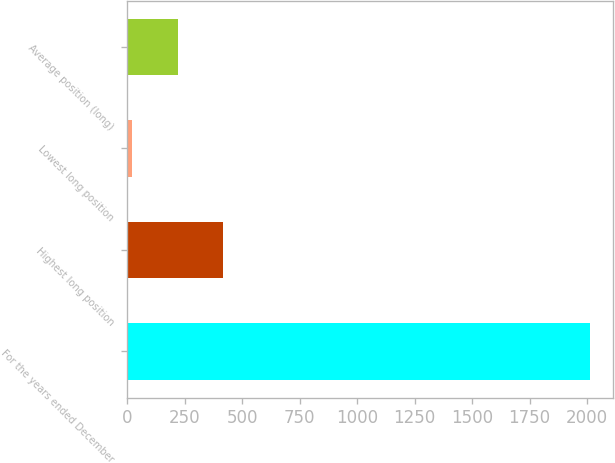Convert chart to OTSL. <chart><loc_0><loc_0><loc_500><loc_500><bar_chart><fcel>For the years ended December<fcel>Highest long position<fcel>Lowest long position<fcel>Average position (long)<nl><fcel>2011<fcel>418.6<fcel>20.5<fcel>219.55<nl></chart> 